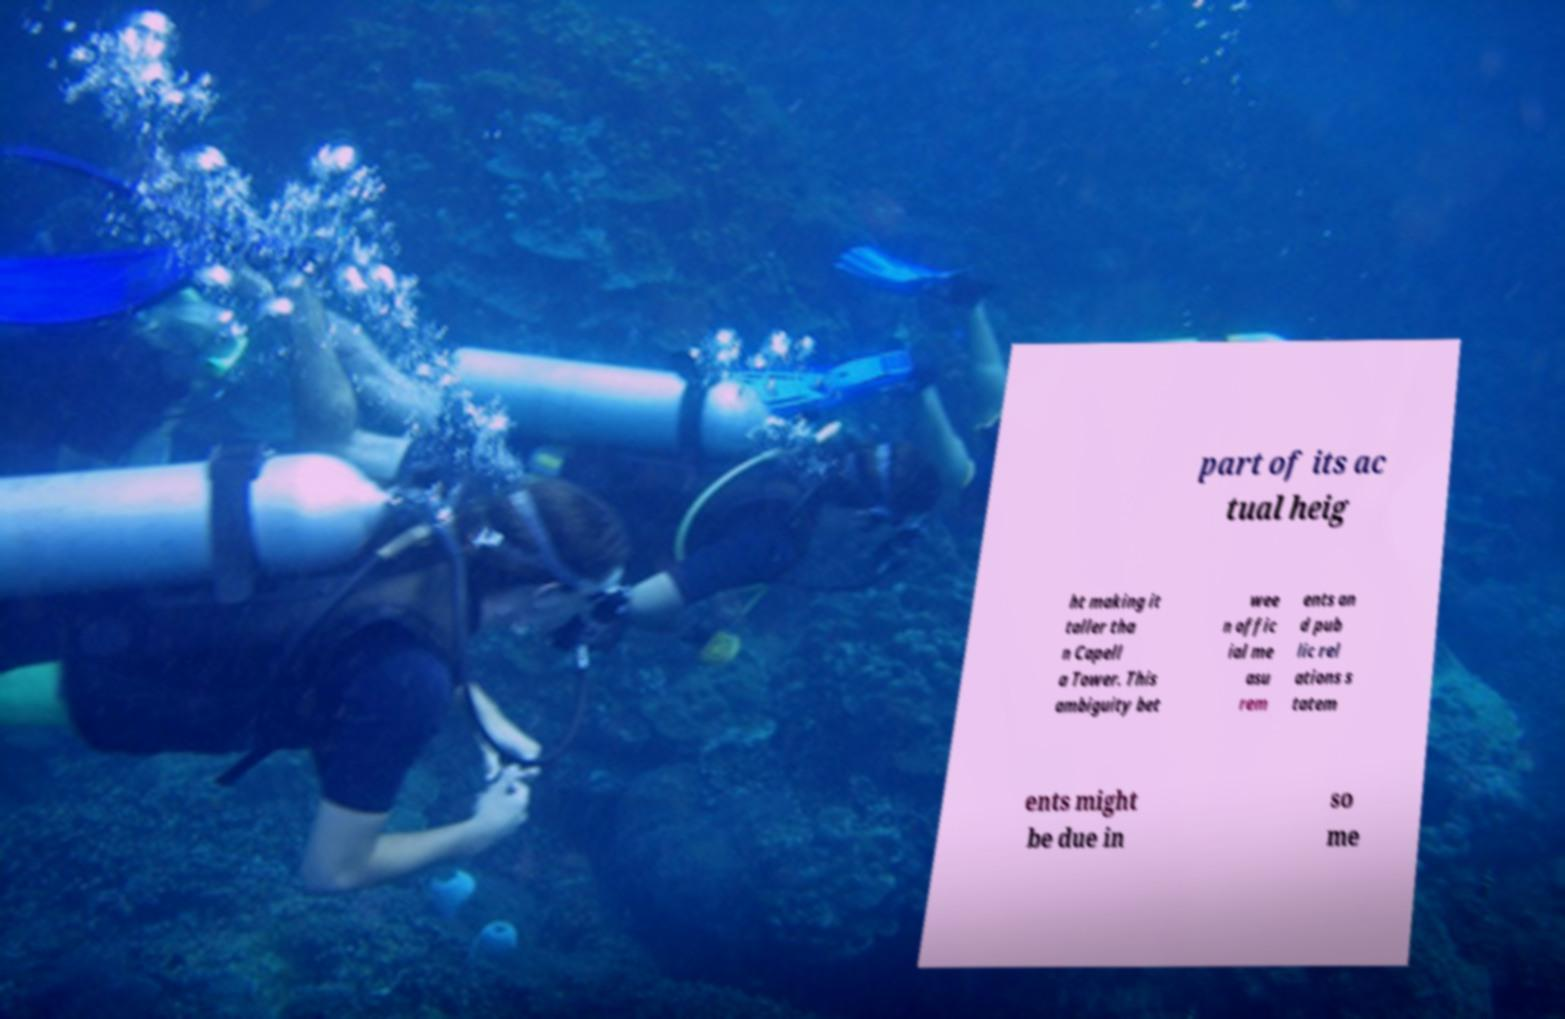There's text embedded in this image that I need extracted. Can you transcribe it verbatim? part of its ac tual heig ht making it taller tha n Capell a Tower. This ambiguity bet wee n offic ial me asu rem ents an d pub lic rel ations s tatem ents might be due in so me 